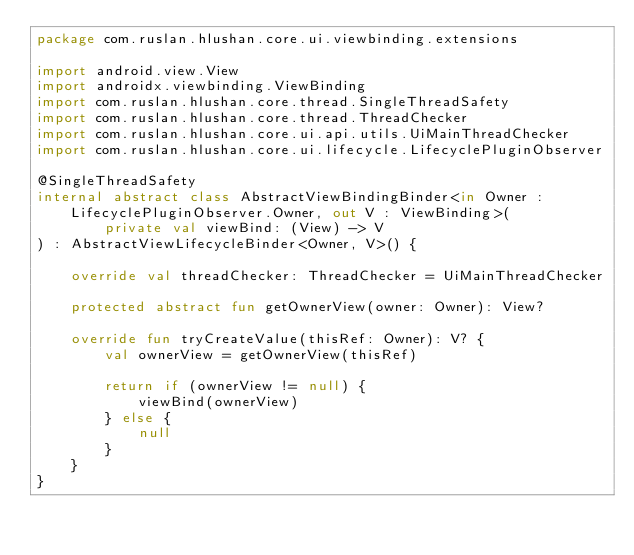Convert code to text. <code><loc_0><loc_0><loc_500><loc_500><_Kotlin_>package com.ruslan.hlushan.core.ui.viewbinding.extensions

import android.view.View
import androidx.viewbinding.ViewBinding
import com.ruslan.hlushan.core.thread.SingleThreadSafety
import com.ruslan.hlushan.core.thread.ThreadChecker
import com.ruslan.hlushan.core.ui.api.utils.UiMainThreadChecker
import com.ruslan.hlushan.core.ui.lifecycle.LifecyclePluginObserver

@SingleThreadSafety
internal abstract class AbstractViewBindingBinder<in Owner : LifecyclePluginObserver.Owner, out V : ViewBinding>(
        private val viewBind: (View) -> V
) : AbstractViewLifecycleBinder<Owner, V>() {

    override val threadChecker: ThreadChecker = UiMainThreadChecker

    protected abstract fun getOwnerView(owner: Owner): View?

    override fun tryCreateValue(thisRef: Owner): V? {
        val ownerView = getOwnerView(thisRef)

        return if (ownerView != null) {
            viewBind(ownerView)
        } else {
            null
        }
    }
}</code> 